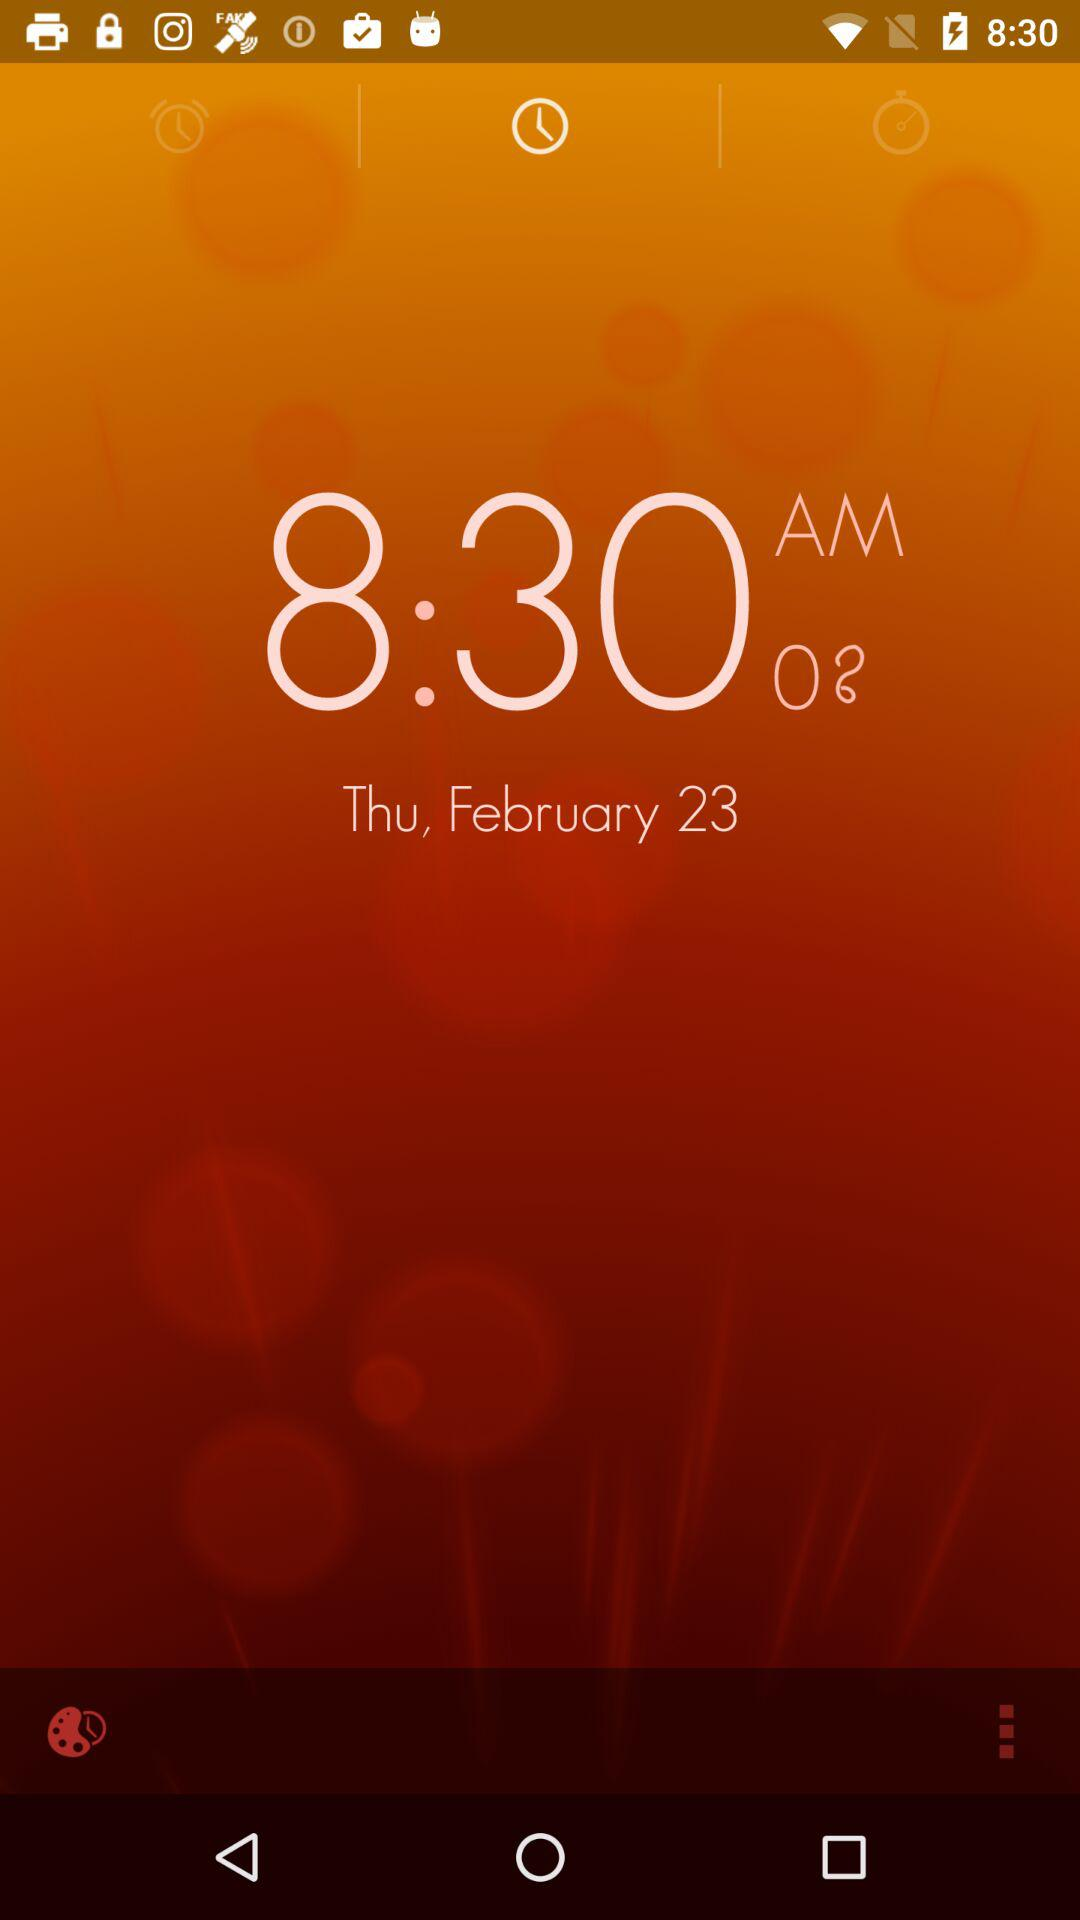Which day falls on 23rd of February? The day is Thursday. 